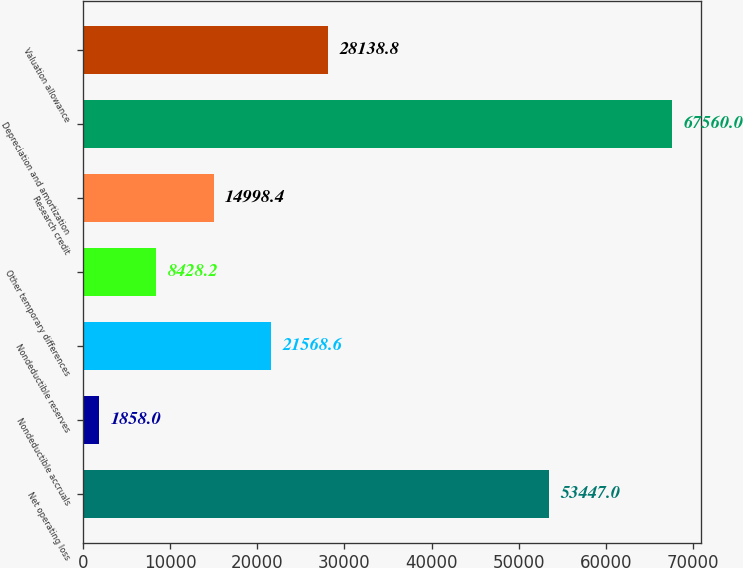Convert chart. <chart><loc_0><loc_0><loc_500><loc_500><bar_chart><fcel>Net operating loss<fcel>Nondeductible accruals<fcel>Nondeductible reserves<fcel>Other temporary differences<fcel>Research credit<fcel>Depreciation and amortization<fcel>Valuation allowance<nl><fcel>53447<fcel>1858<fcel>21568.6<fcel>8428.2<fcel>14998.4<fcel>67560<fcel>28138.8<nl></chart> 